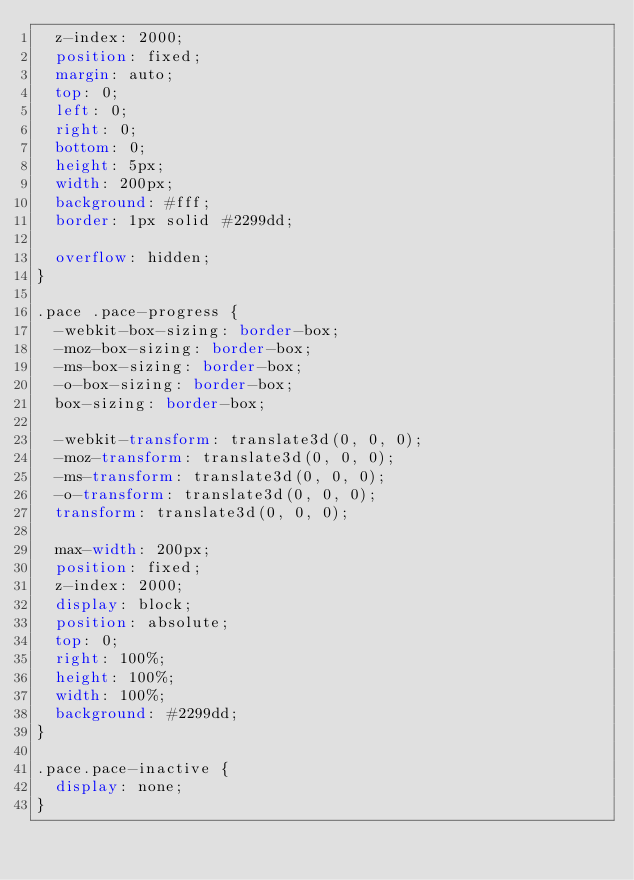Convert code to text. <code><loc_0><loc_0><loc_500><loc_500><_CSS_>  z-index: 2000;
  position: fixed;
  margin: auto;
  top: 0;
  left: 0;
  right: 0;
  bottom: 0;
  height: 5px;
  width: 200px;
  background: #fff;
  border: 1px solid #2299dd;

  overflow: hidden;
}

.pace .pace-progress {
  -webkit-box-sizing: border-box;
  -moz-box-sizing: border-box;
  -ms-box-sizing: border-box;
  -o-box-sizing: border-box;
  box-sizing: border-box;

  -webkit-transform: translate3d(0, 0, 0);
  -moz-transform: translate3d(0, 0, 0);
  -ms-transform: translate3d(0, 0, 0);
  -o-transform: translate3d(0, 0, 0);
  transform: translate3d(0, 0, 0);

  max-width: 200px;
  position: fixed;
  z-index: 2000;
  display: block;
  position: absolute;
  top: 0;
  right: 100%;
  height: 100%;
  width: 100%;
  background: #2299dd;
}

.pace.pace-inactive {
  display: none;
}
</code> 